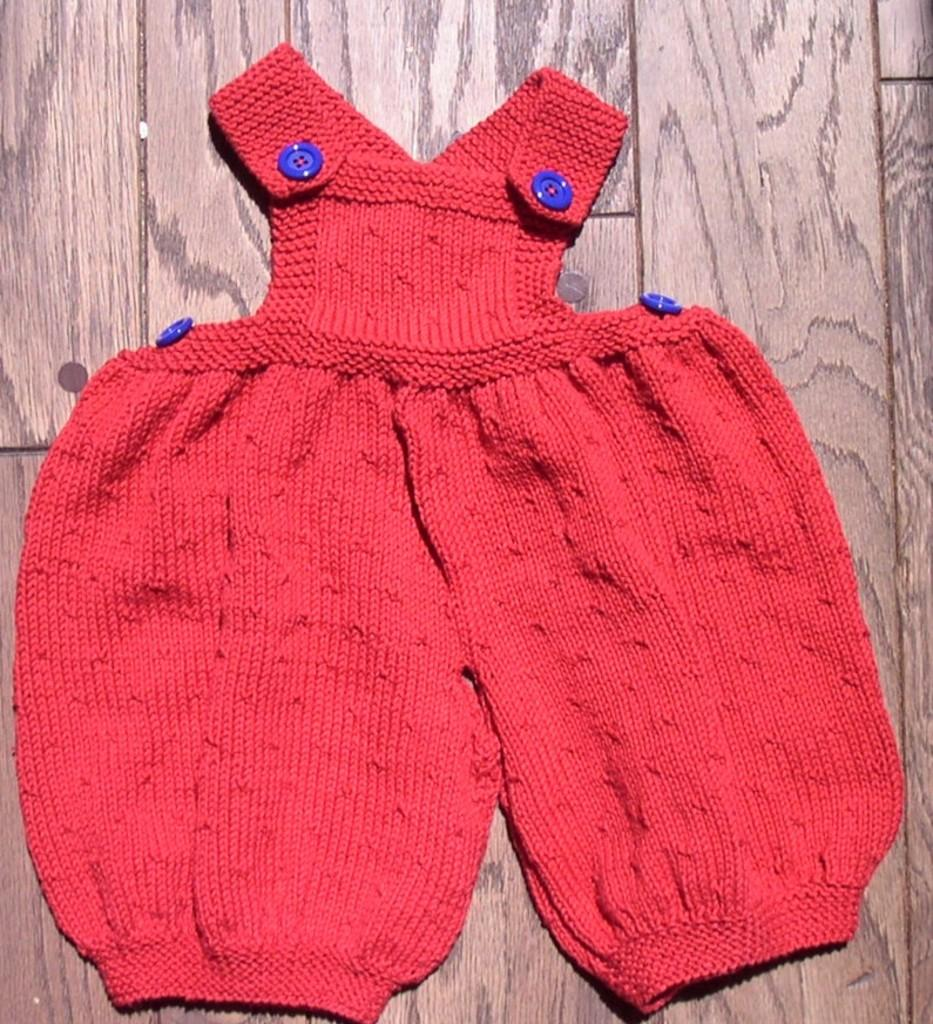What type of clothing item is in the image? There is a baby dress in the image. What color is the baby dress? The baby dress is red in color. On what surface is the baby dress placed? The baby dress is on a wooden surface. Is the baby dress made of canvas material? No, the baby dress is not made of canvas material; it is placed on a wooden surface. 